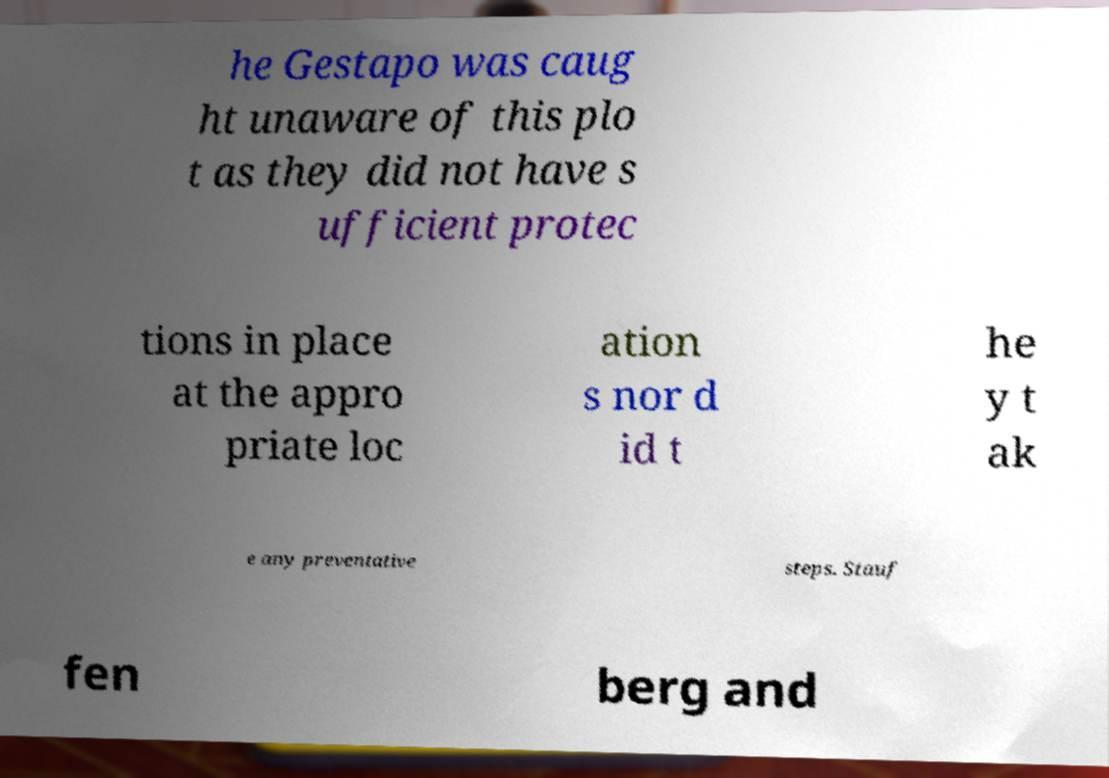I need the written content from this picture converted into text. Can you do that? he Gestapo was caug ht unaware of this plo t as they did not have s ufficient protec tions in place at the appro priate loc ation s nor d id t he y t ak e any preventative steps. Stauf fen berg and 